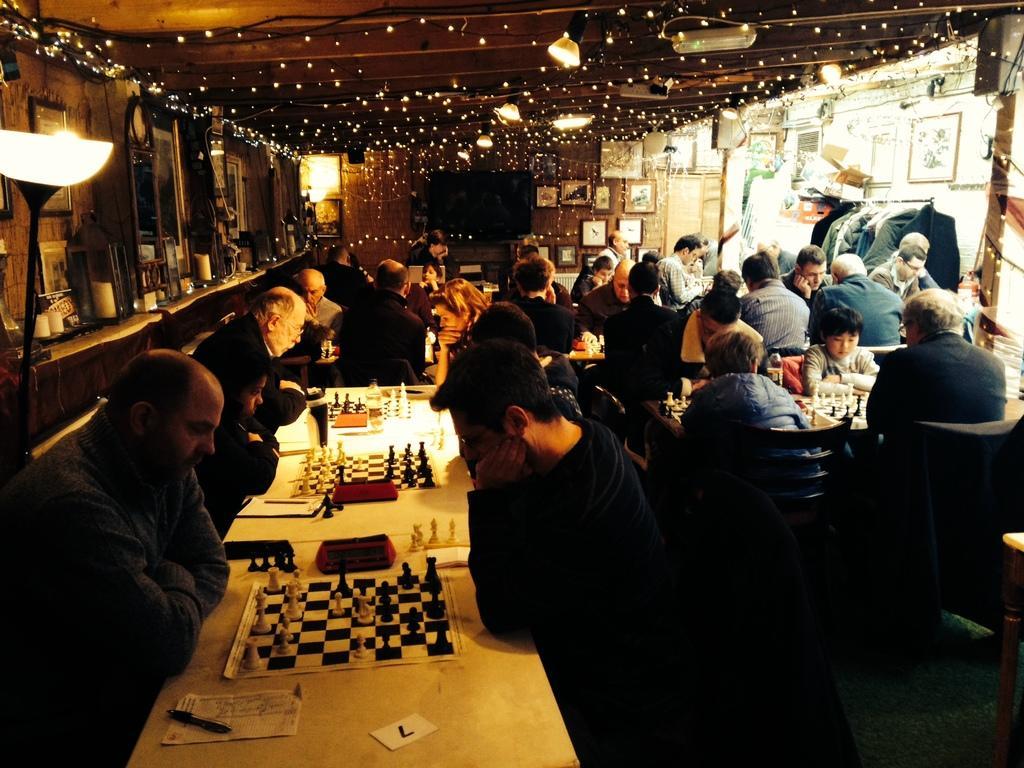In one or two sentences, can you explain what this image depicts? A group of people are playing together a chess. There are lights at the top. 